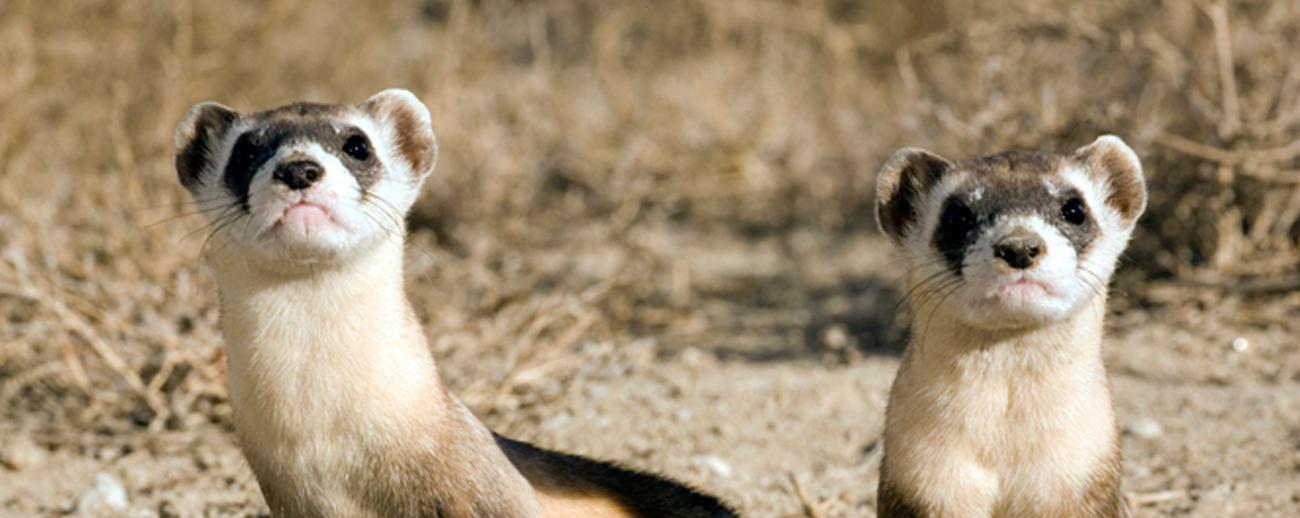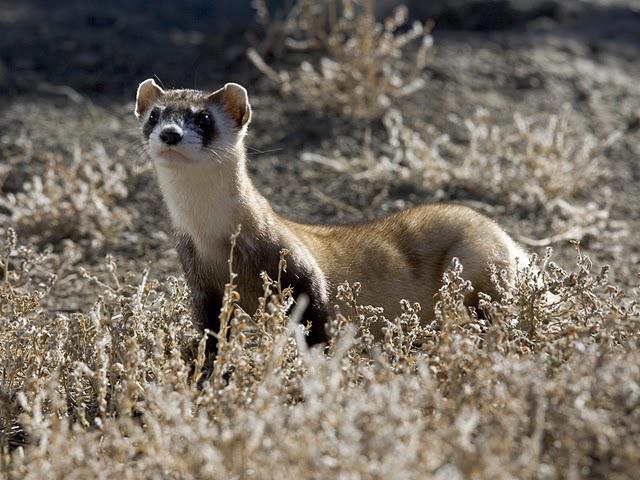The first image is the image on the left, the second image is the image on the right. Examine the images to the left and right. Is the description "There are no more than 3 ferrets shown." accurate? Answer yes or no. Yes. The first image is the image on the left, the second image is the image on the right. Analyze the images presented: Is the assertion "there are exactly three animals in one of the images" valid? Answer yes or no. No. 